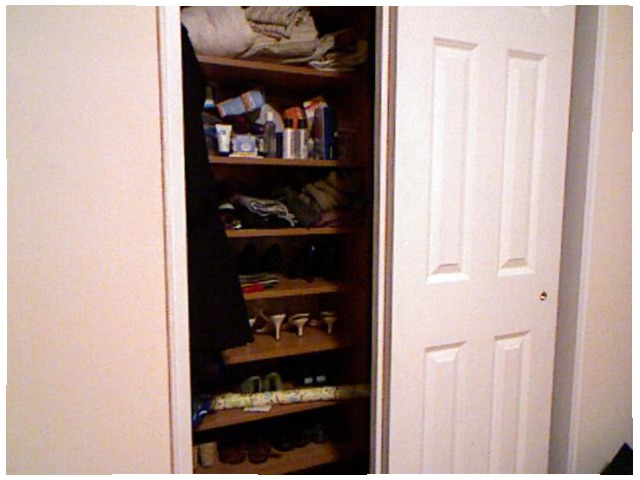<image>
Is there a blankets under the shoes? No. The blankets is not positioned under the shoes. The vertical relationship between these objects is different. 